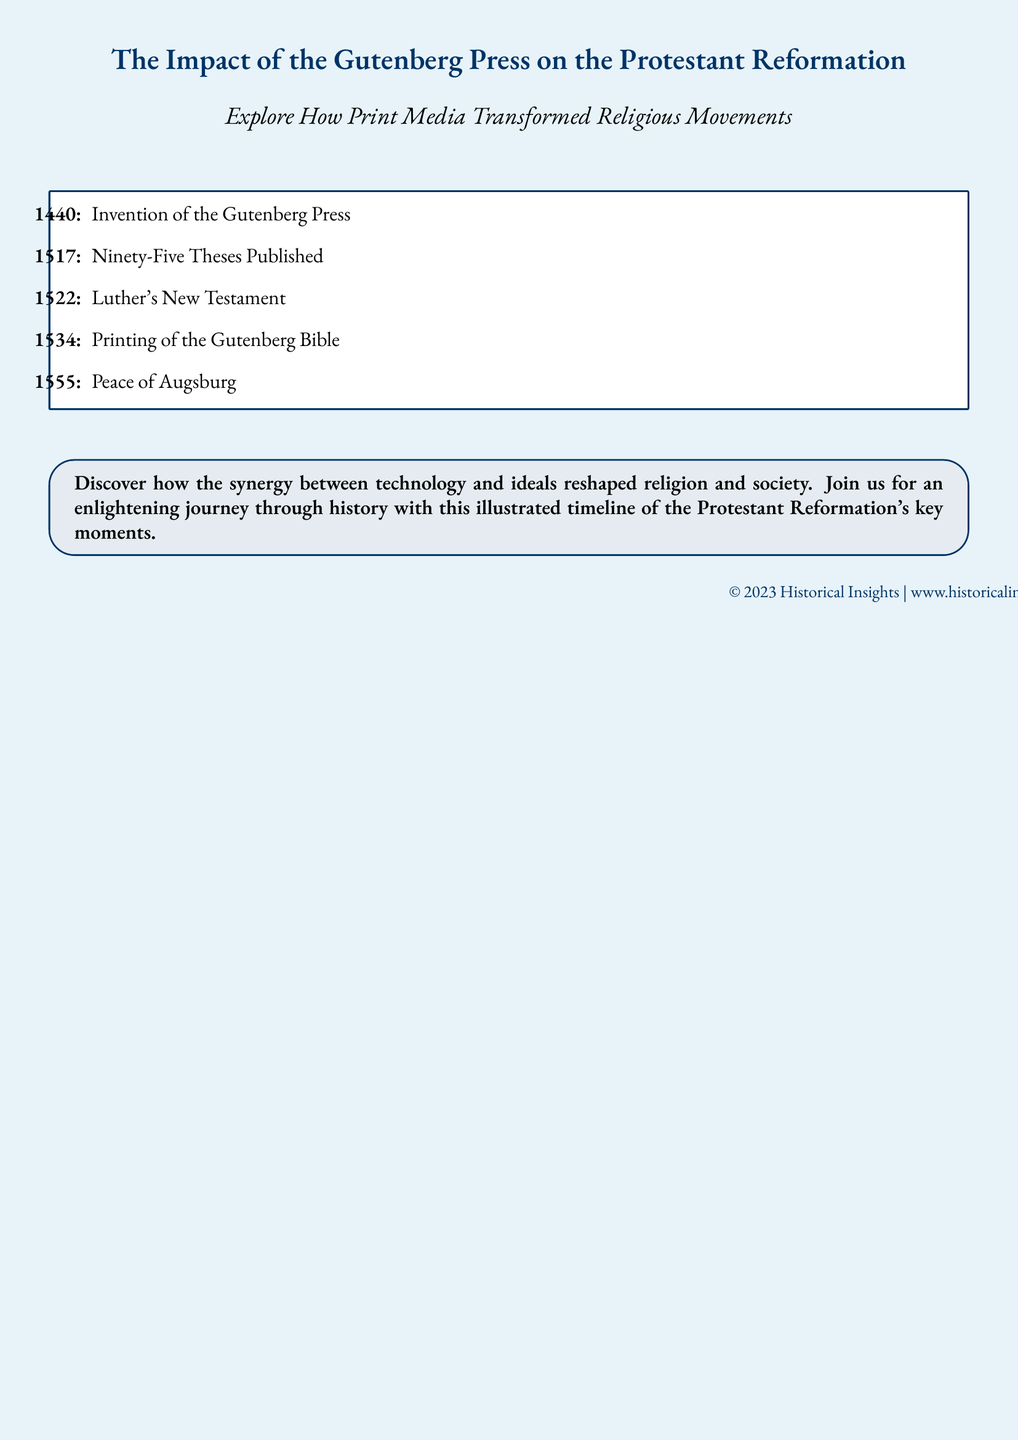What year was the Gutenberg Press invented? The document states that the invention of the Gutenberg Press occurred in the year 1440.
Answer: 1440 What significant document did Martin Luther publish in 1517? According to the timeline, Martin Luther published the Ninety-Five Theses in 1517.
Answer: Ninety-Five Theses What is the title of Luther's work printed in 1522? The document mentions that Luther's New Testament was published in 1522.
Answer: Luther's New Testament What important event in 1555 is mentioned in the timeline? The timeline refers to the Peace of Augsburg as a key event in 1555.
Answer: Peace of Augsburg How did the Gutenberg Press impact the Protestant Reformation? The document highlights that the synergy between technology and ideals reshaped religion and society, indicating its transformative impact.
Answer: Transformed religion and society What type of media does this advertisement focus on? The advertisement emphasizes the role of print media in transforming religious movements during the Reformation.
Answer: Print media What does the illustrated timeline aim to provide? The document states that the illustrated timeline aims to provide an enlightening journey through history regarding key moments of the Protestant Reformation.
Answer: Enlightening journey through history Who published the document? The footer indicates that the document is published by Historical Insights.
Answer: Historical Insights 